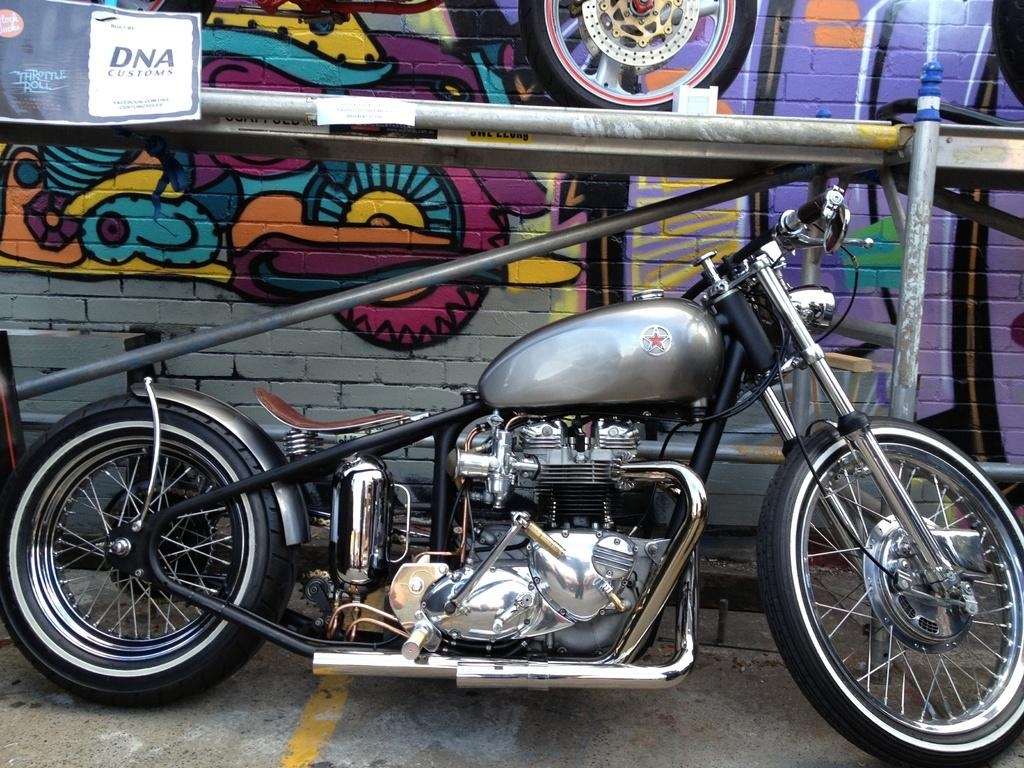What is the main subject of the image? There is a motorbike in the image. What can be seen in the background of the image? There is a tire, a paper, iron grills, and graffiti on a wall in the background of the image. What year is depicted in the graffiti on the wall in the image? There is no specific year mentioned in the graffiti on the wall in the image. Can you spot a squirrel hiding behind the tire in the background of the image? There is no squirrel present in the image. 